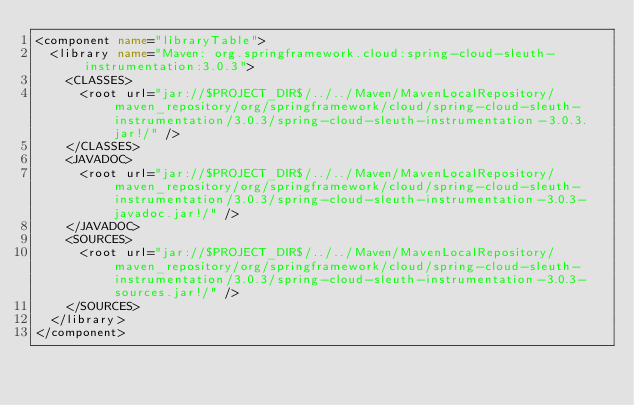Convert code to text. <code><loc_0><loc_0><loc_500><loc_500><_XML_><component name="libraryTable">
  <library name="Maven: org.springframework.cloud:spring-cloud-sleuth-instrumentation:3.0.3">
    <CLASSES>
      <root url="jar://$PROJECT_DIR$/../../Maven/MavenLocalRepository/maven_repository/org/springframework/cloud/spring-cloud-sleuth-instrumentation/3.0.3/spring-cloud-sleuth-instrumentation-3.0.3.jar!/" />
    </CLASSES>
    <JAVADOC>
      <root url="jar://$PROJECT_DIR$/../../Maven/MavenLocalRepository/maven_repository/org/springframework/cloud/spring-cloud-sleuth-instrumentation/3.0.3/spring-cloud-sleuth-instrumentation-3.0.3-javadoc.jar!/" />
    </JAVADOC>
    <SOURCES>
      <root url="jar://$PROJECT_DIR$/../../Maven/MavenLocalRepository/maven_repository/org/springframework/cloud/spring-cloud-sleuth-instrumentation/3.0.3/spring-cloud-sleuth-instrumentation-3.0.3-sources.jar!/" />
    </SOURCES>
  </library>
</component></code> 